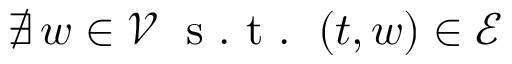<formula> <loc_0><loc_0><loc_500><loc_500>\nexists \, w \in \mathcal { V } \, s . t . \, ( t , w ) \in \mathcal { E }</formula> 